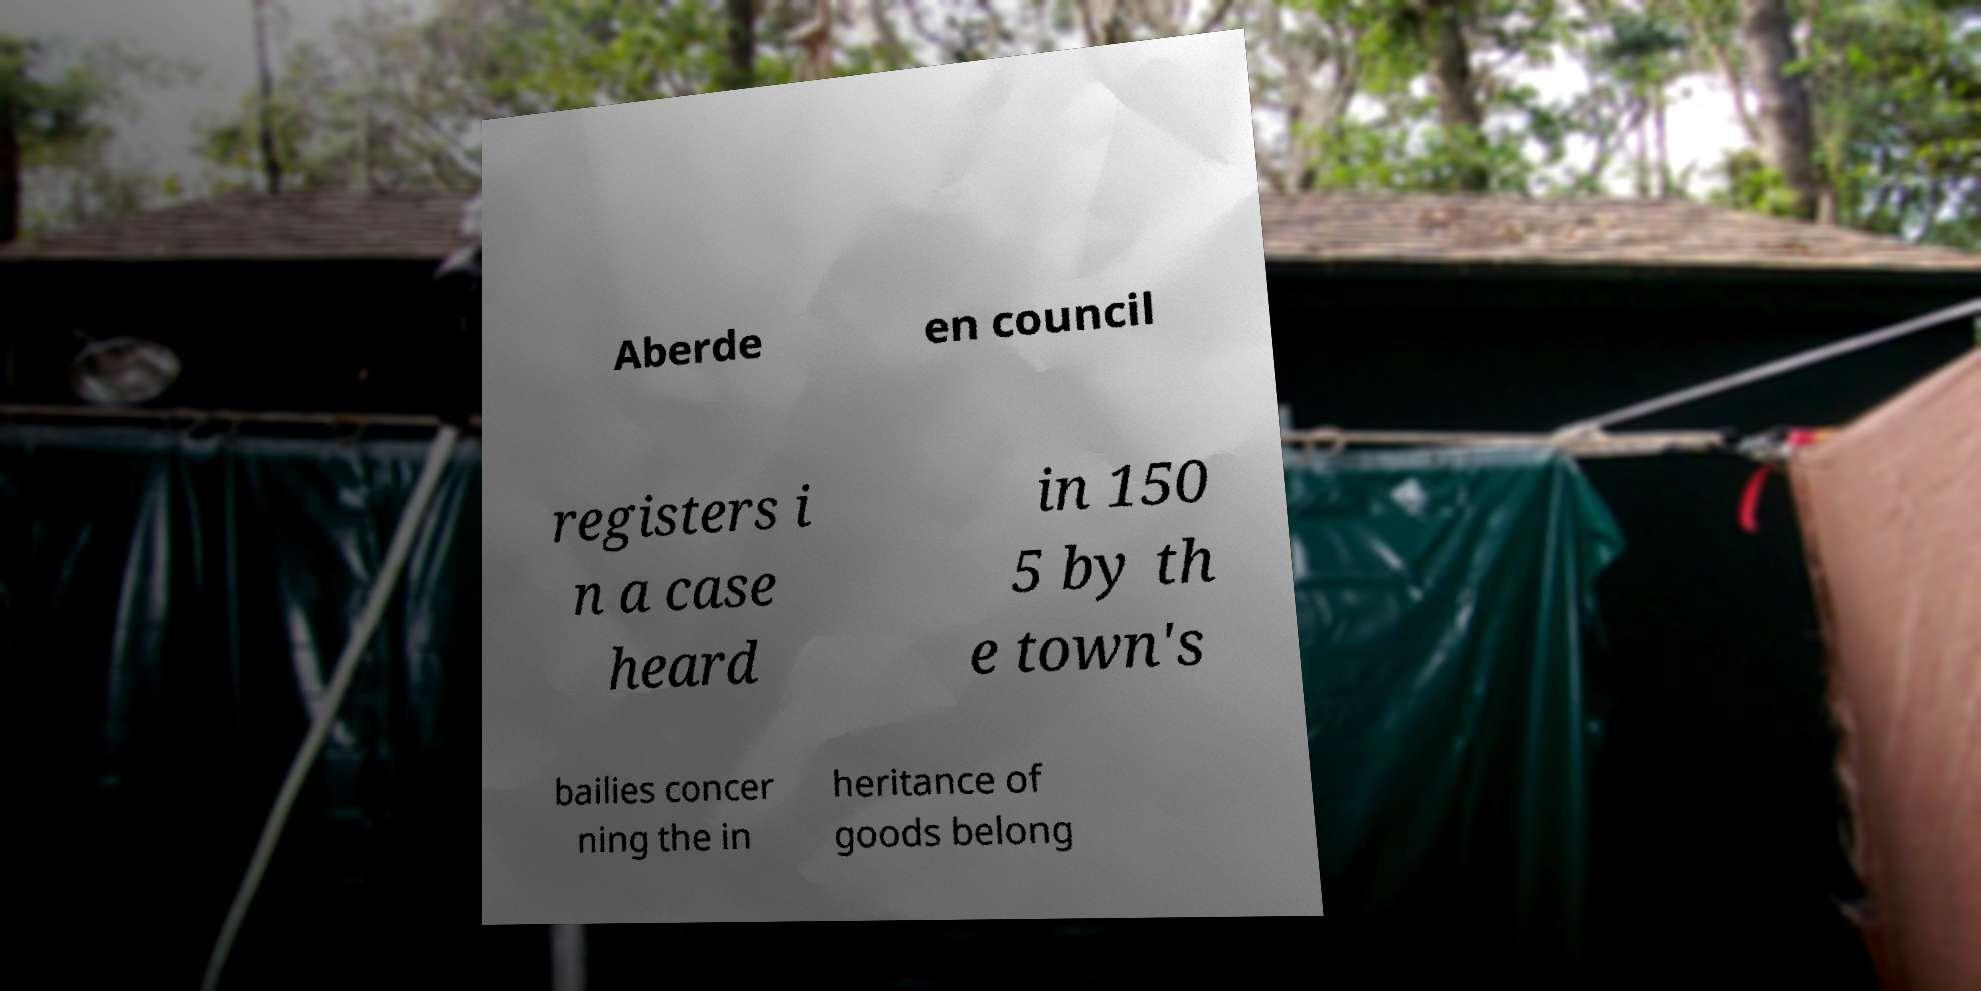Could you assist in decoding the text presented in this image and type it out clearly? Aberde en council registers i n a case heard in 150 5 by th e town's bailies concer ning the in heritance of goods belong 